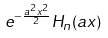Convert formula to latex. <formula><loc_0><loc_0><loc_500><loc_500>e ^ { - { \frac { a ^ { 2 } x ^ { 2 } } { 2 } } } H _ { n } ( a x )</formula> 